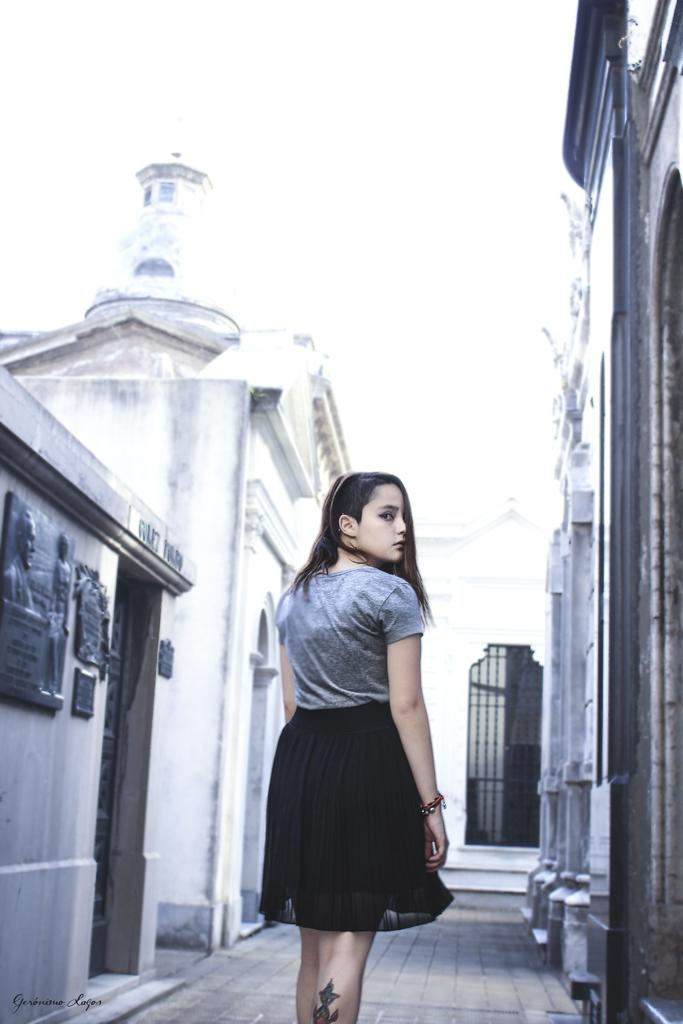What is the main subject of the image? There is a beautiful woman in the image. What is the woman doing in the image? The woman is walking in the street. What colors can be seen in the woman's outfit? The woman is wearing a grey color top and a black color frock. What can be seen in the background of the image? There are buildings on either side of the image. Can you see the sun in the image? There is no sun visible in the image. Is the woman wearing a badge in the image? There is no badge visible on the woman in the image. 